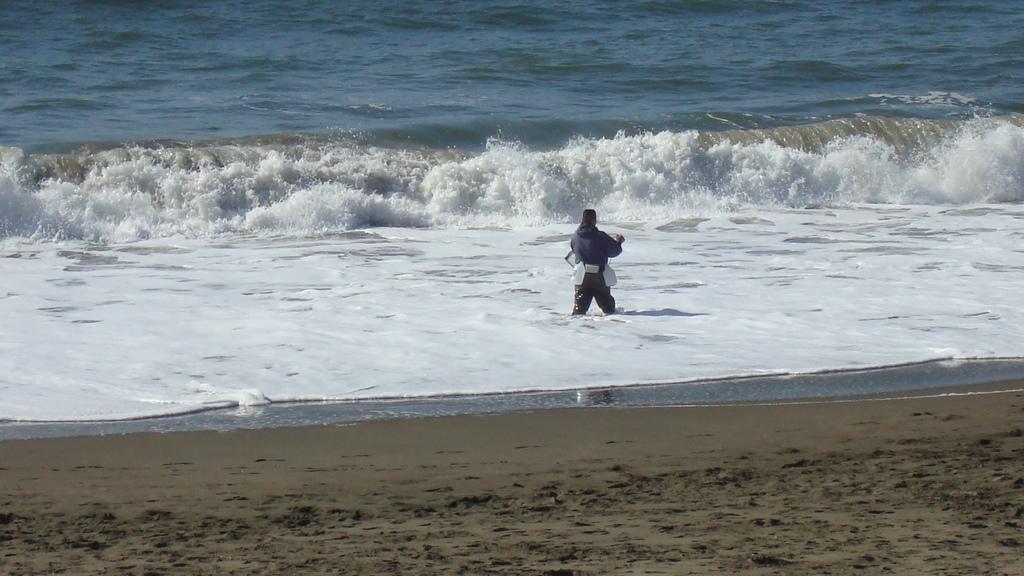Describe this image in one or two sentences. In this picture we can see a person standing in the water. Waves are visible from left to right in the water. We can see sand at the bottom of the picture. 